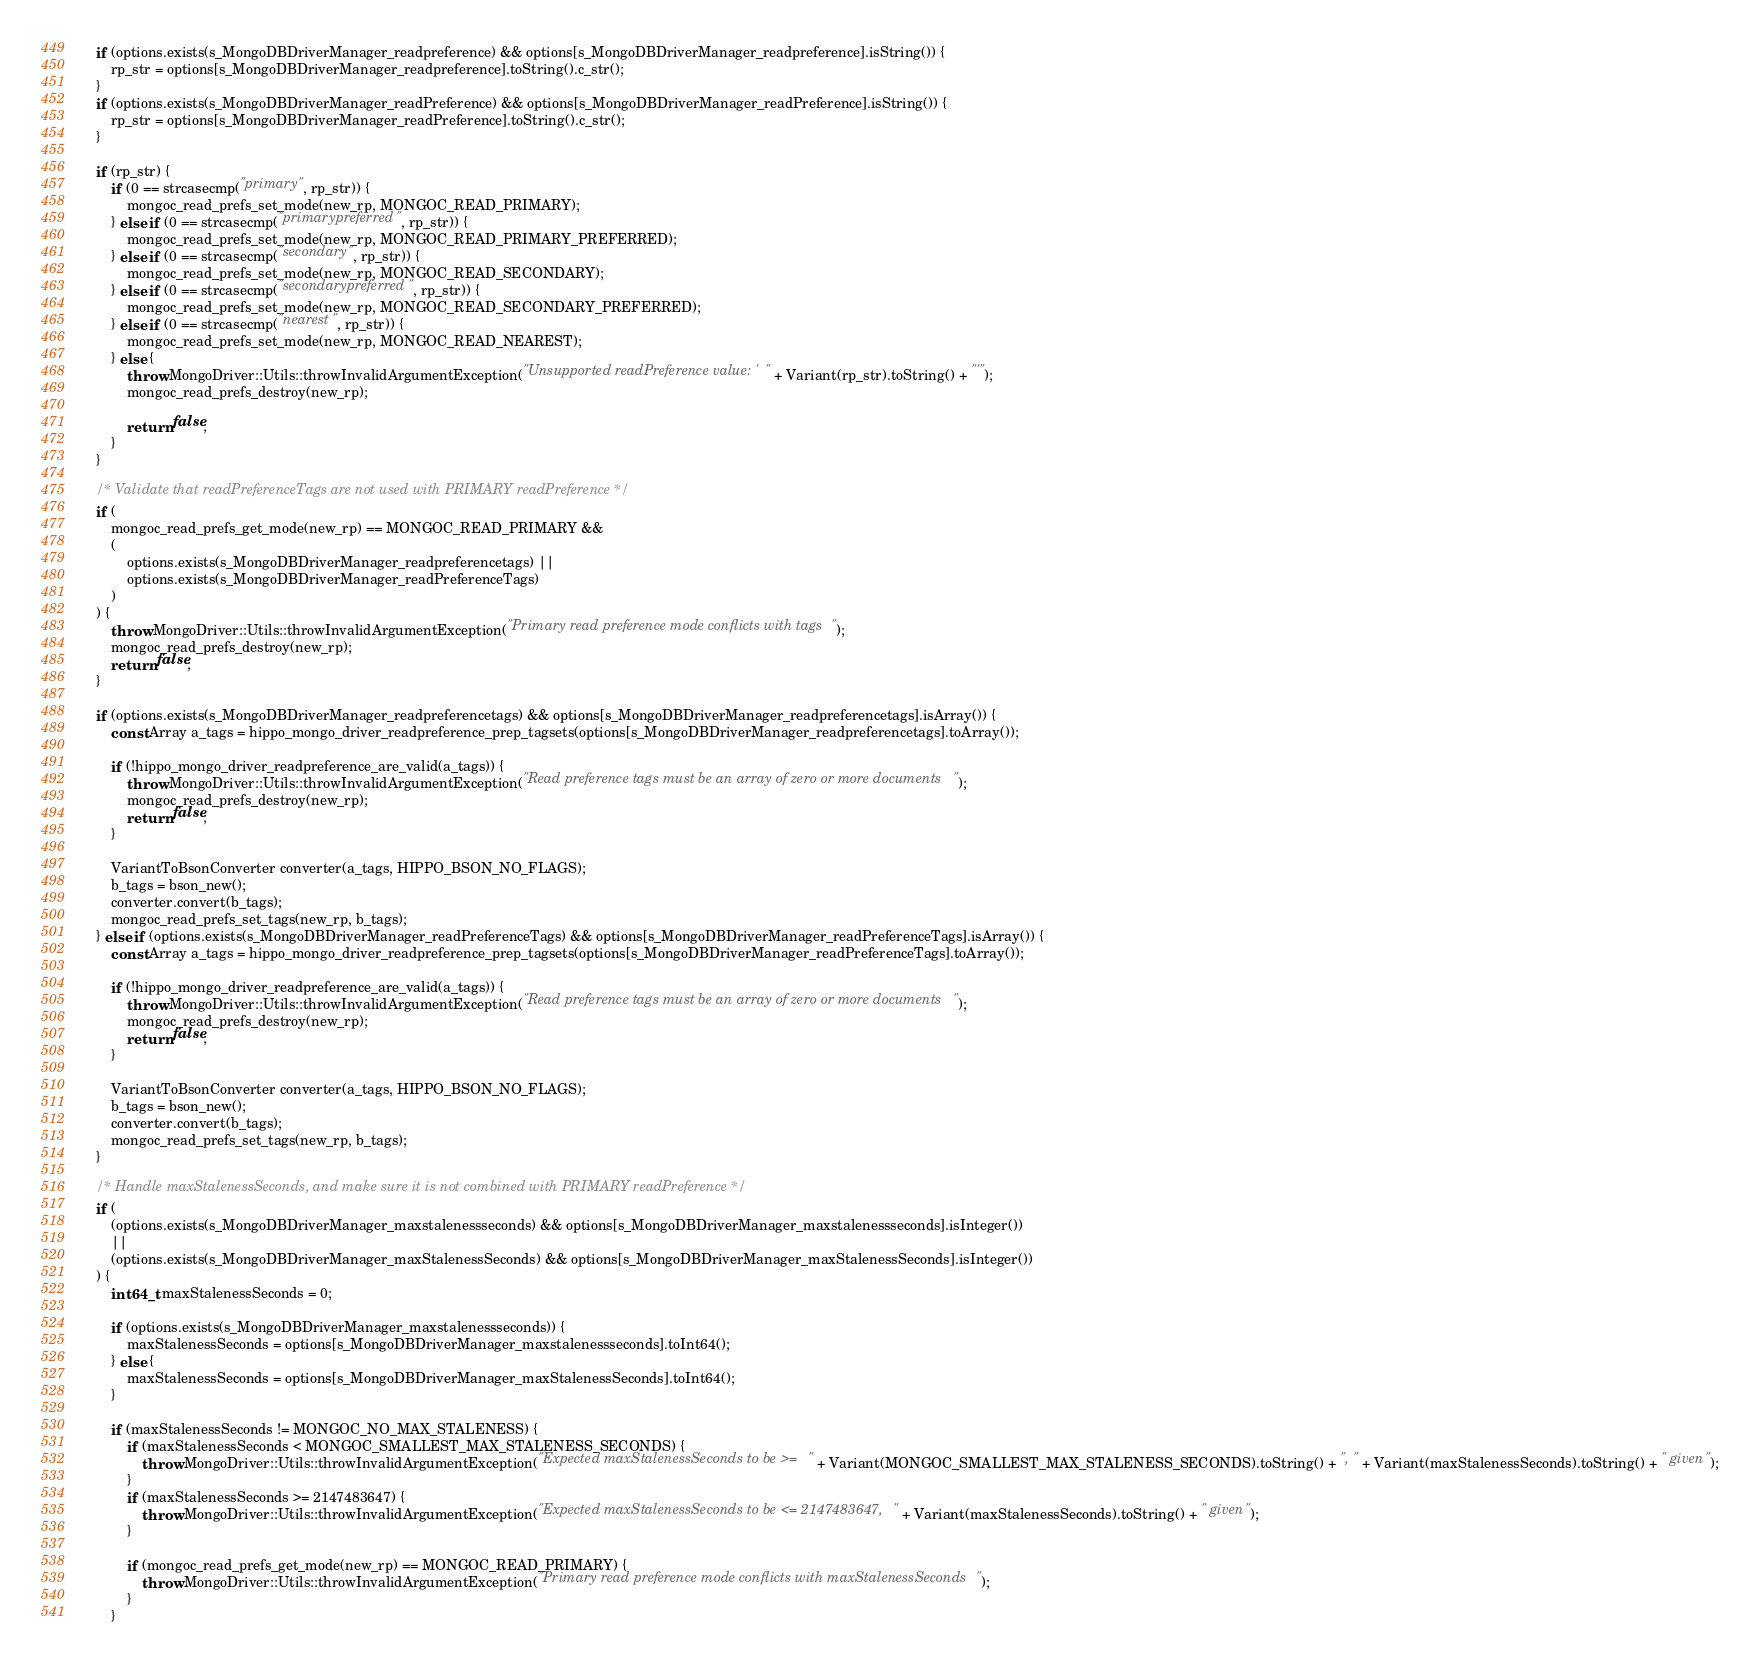<code> <loc_0><loc_0><loc_500><loc_500><_C++_>	if (options.exists(s_MongoDBDriverManager_readpreference) && options[s_MongoDBDriverManager_readpreference].isString()) {
		rp_str = options[s_MongoDBDriverManager_readpreference].toString().c_str();
	}
	if (options.exists(s_MongoDBDriverManager_readPreference) && options[s_MongoDBDriverManager_readPreference].isString()) {
		rp_str = options[s_MongoDBDriverManager_readPreference].toString().c_str();
	}

	if (rp_str) {
		if (0 == strcasecmp("primary", rp_str)) {
			mongoc_read_prefs_set_mode(new_rp, MONGOC_READ_PRIMARY);
		} else if (0 == strcasecmp("primarypreferred", rp_str)) {
			mongoc_read_prefs_set_mode(new_rp, MONGOC_READ_PRIMARY_PREFERRED);
		} else if (0 == strcasecmp("secondary", rp_str)) {
			mongoc_read_prefs_set_mode(new_rp, MONGOC_READ_SECONDARY);
		} else if (0 == strcasecmp("secondarypreferred", rp_str)) {
			mongoc_read_prefs_set_mode(new_rp, MONGOC_READ_SECONDARY_PREFERRED);
		} else if (0 == strcasecmp("nearest", rp_str)) {
			mongoc_read_prefs_set_mode(new_rp, MONGOC_READ_NEAREST);
		} else {
			throw MongoDriver::Utils::throwInvalidArgumentException("Unsupported readPreference value: '" + Variant(rp_str).toString() + "'");
			mongoc_read_prefs_destroy(new_rp);

			return false;
		}
	}

	/* Validate that readPreferenceTags are not used with PRIMARY readPreference */
	if (
		mongoc_read_prefs_get_mode(new_rp) == MONGOC_READ_PRIMARY &&
		(
			options.exists(s_MongoDBDriverManager_readpreferencetags) ||
			options.exists(s_MongoDBDriverManager_readPreferenceTags)
		)
	) {
		throw MongoDriver::Utils::throwInvalidArgumentException("Primary read preference mode conflicts with tags");
		mongoc_read_prefs_destroy(new_rp);
		return false;
	}

	if (options.exists(s_MongoDBDriverManager_readpreferencetags) && options[s_MongoDBDriverManager_readpreferencetags].isArray()) {
		const Array a_tags = hippo_mongo_driver_readpreference_prep_tagsets(options[s_MongoDBDriverManager_readpreferencetags].toArray());

		if (!hippo_mongo_driver_readpreference_are_valid(a_tags)) {
			throw MongoDriver::Utils::throwInvalidArgumentException("Read preference tags must be an array of zero or more documents");
			mongoc_read_prefs_destroy(new_rp);
			return false;
		}

		VariantToBsonConverter converter(a_tags, HIPPO_BSON_NO_FLAGS);
		b_tags = bson_new();
		converter.convert(b_tags);
		mongoc_read_prefs_set_tags(new_rp, b_tags);
	} else if (options.exists(s_MongoDBDriverManager_readPreferenceTags) && options[s_MongoDBDriverManager_readPreferenceTags].isArray()) {
		const Array a_tags = hippo_mongo_driver_readpreference_prep_tagsets(options[s_MongoDBDriverManager_readPreferenceTags].toArray());

		if (!hippo_mongo_driver_readpreference_are_valid(a_tags)) {
			throw MongoDriver::Utils::throwInvalidArgumentException("Read preference tags must be an array of zero or more documents");
			mongoc_read_prefs_destroy(new_rp);
			return false;
		}

		VariantToBsonConverter converter(a_tags, HIPPO_BSON_NO_FLAGS);
		b_tags = bson_new();
		converter.convert(b_tags);
		mongoc_read_prefs_set_tags(new_rp, b_tags);
	}

	/* Handle maxStalenessSeconds, and make sure it is not combined with PRIMARY readPreference */
	if (
		(options.exists(s_MongoDBDriverManager_maxstalenessseconds) && options[s_MongoDBDriverManager_maxstalenessseconds].isInteger())
		||
		(options.exists(s_MongoDBDriverManager_maxStalenessSeconds) && options[s_MongoDBDriverManager_maxStalenessSeconds].isInteger())
	) {
		int64_t maxStalenessSeconds = 0;

		if (options.exists(s_MongoDBDriverManager_maxstalenessseconds)) {
			maxStalenessSeconds = options[s_MongoDBDriverManager_maxstalenessseconds].toInt64();
		} else {
			maxStalenessSeconds = options[s_MongoDBDriverManager_maxStalenessSeconds].toInt64();
		}

		if (maxStalenessSeconds != MONGOC_NO_MAX_STALENESS) {
			if (maxStalenessSeconds < MONGOC_SMALLEST_MAX_STALENESS_SECONDS) {
				throw MongoDriver::Utils::throwInvalidArgumentException("Expected maxStalenessSeconds to be >= " + Variant(MONGOC_SMALLEST_MAX_STALENESS_SECONDS).toString() + ", " + Variant(maxStalenessSeconds).toString() + " given");
			}
			if (maxStalenessSeconds >= 2147483647) {
				throw MongoDriver::Utils::throwInvalidArgumentException("Expected maxStalenessSeconds to be <= 2147483647, " + Variant(maxStalenessSeconds).toString() + " given");
			}

			if (mongoc_read_prefs_get_mode(new_rp) == MONGOC_READ_PRIMARY) {
				throw MongoDriver::Utils::throwInvalidArgumentException("Primary read preference mode conflicts with maxStalenessSeconds");
			}
		}
</code> 